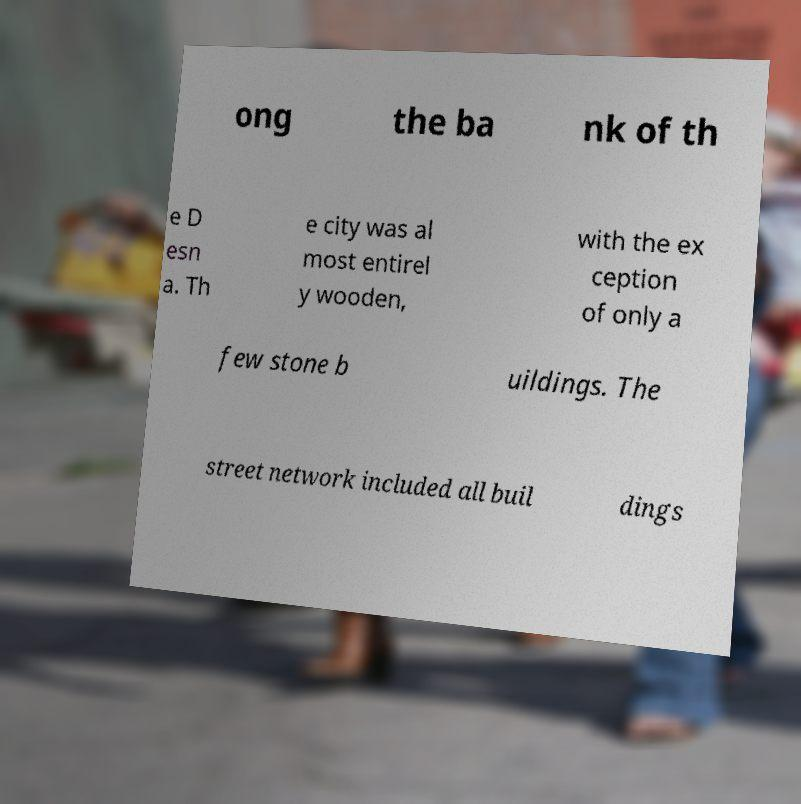Can you accurately transcribe the text from the provided image for me? ong the ba nk of th e D esn a. Th e city was al most entirel y wooden, with the ex ception of only a few stone b uildings. The street network included all buil dings 